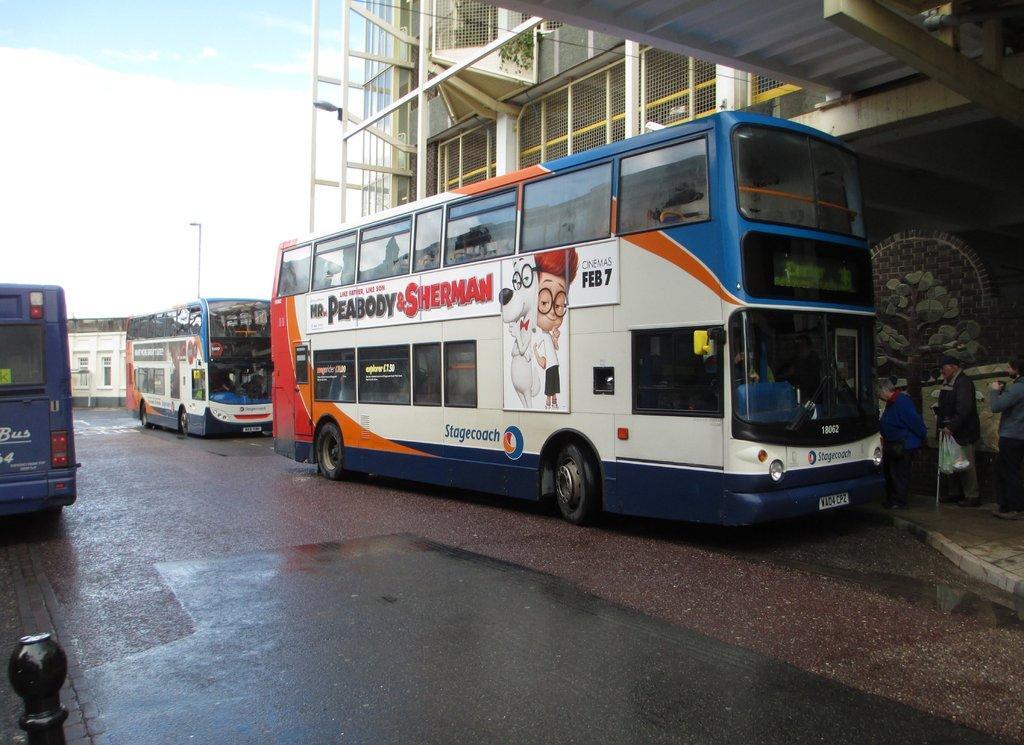How would you summarize this image in a sentence or two? In this image I can see the vehicles. To the right I can see three people with different color dresses. In the background I can see the buildings, pole, clouds and the sky. 